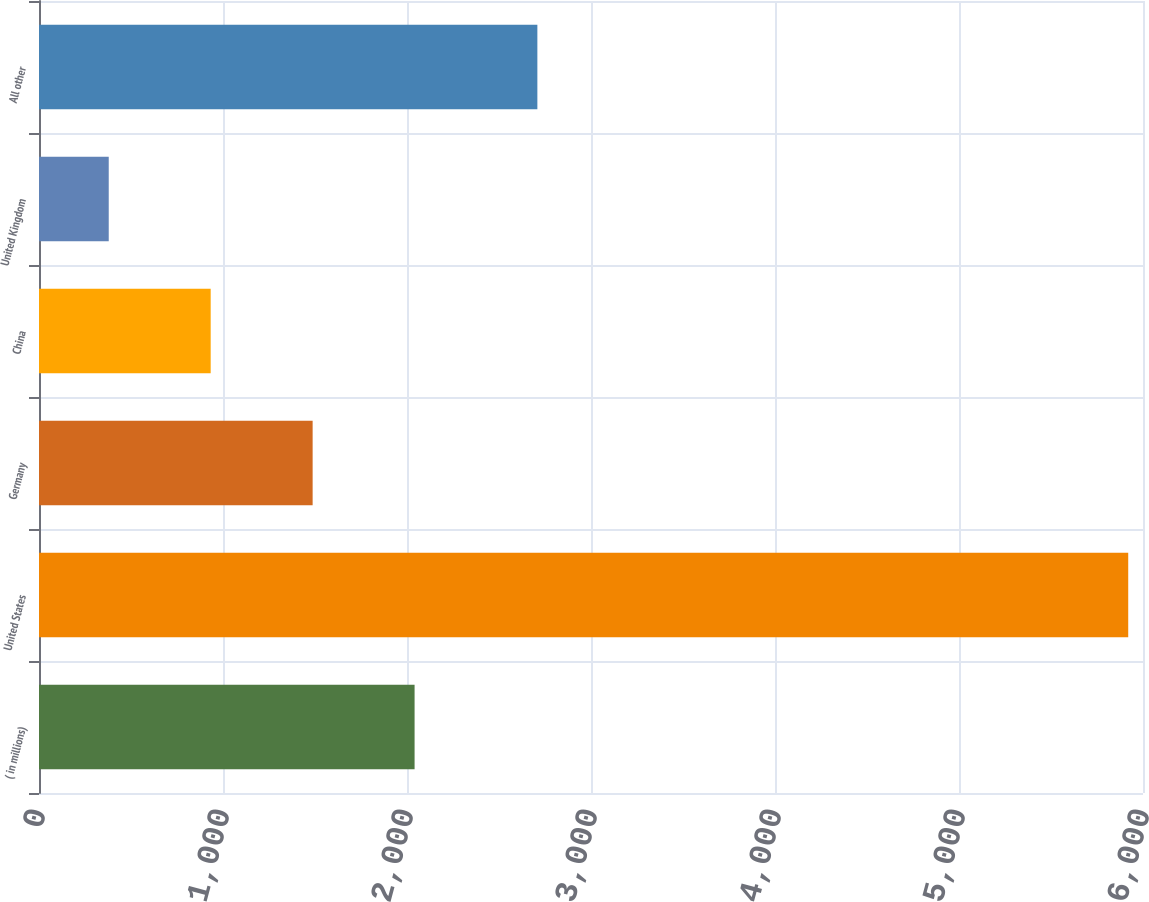Convert chart to OTSL. <chart><loc_0><loc_0><loc_500><loc_500><bar_chart><fcel>( in millions)<fcel>United States<fcel>Germany<fcel>China<fcel>United Kingdom<fcel>All other<nl><fcel>2041.21<fcel>5919.7<fcel>1487.14<fcel>933.07<fcel>379<fcel>2708.5<nl></chart> 